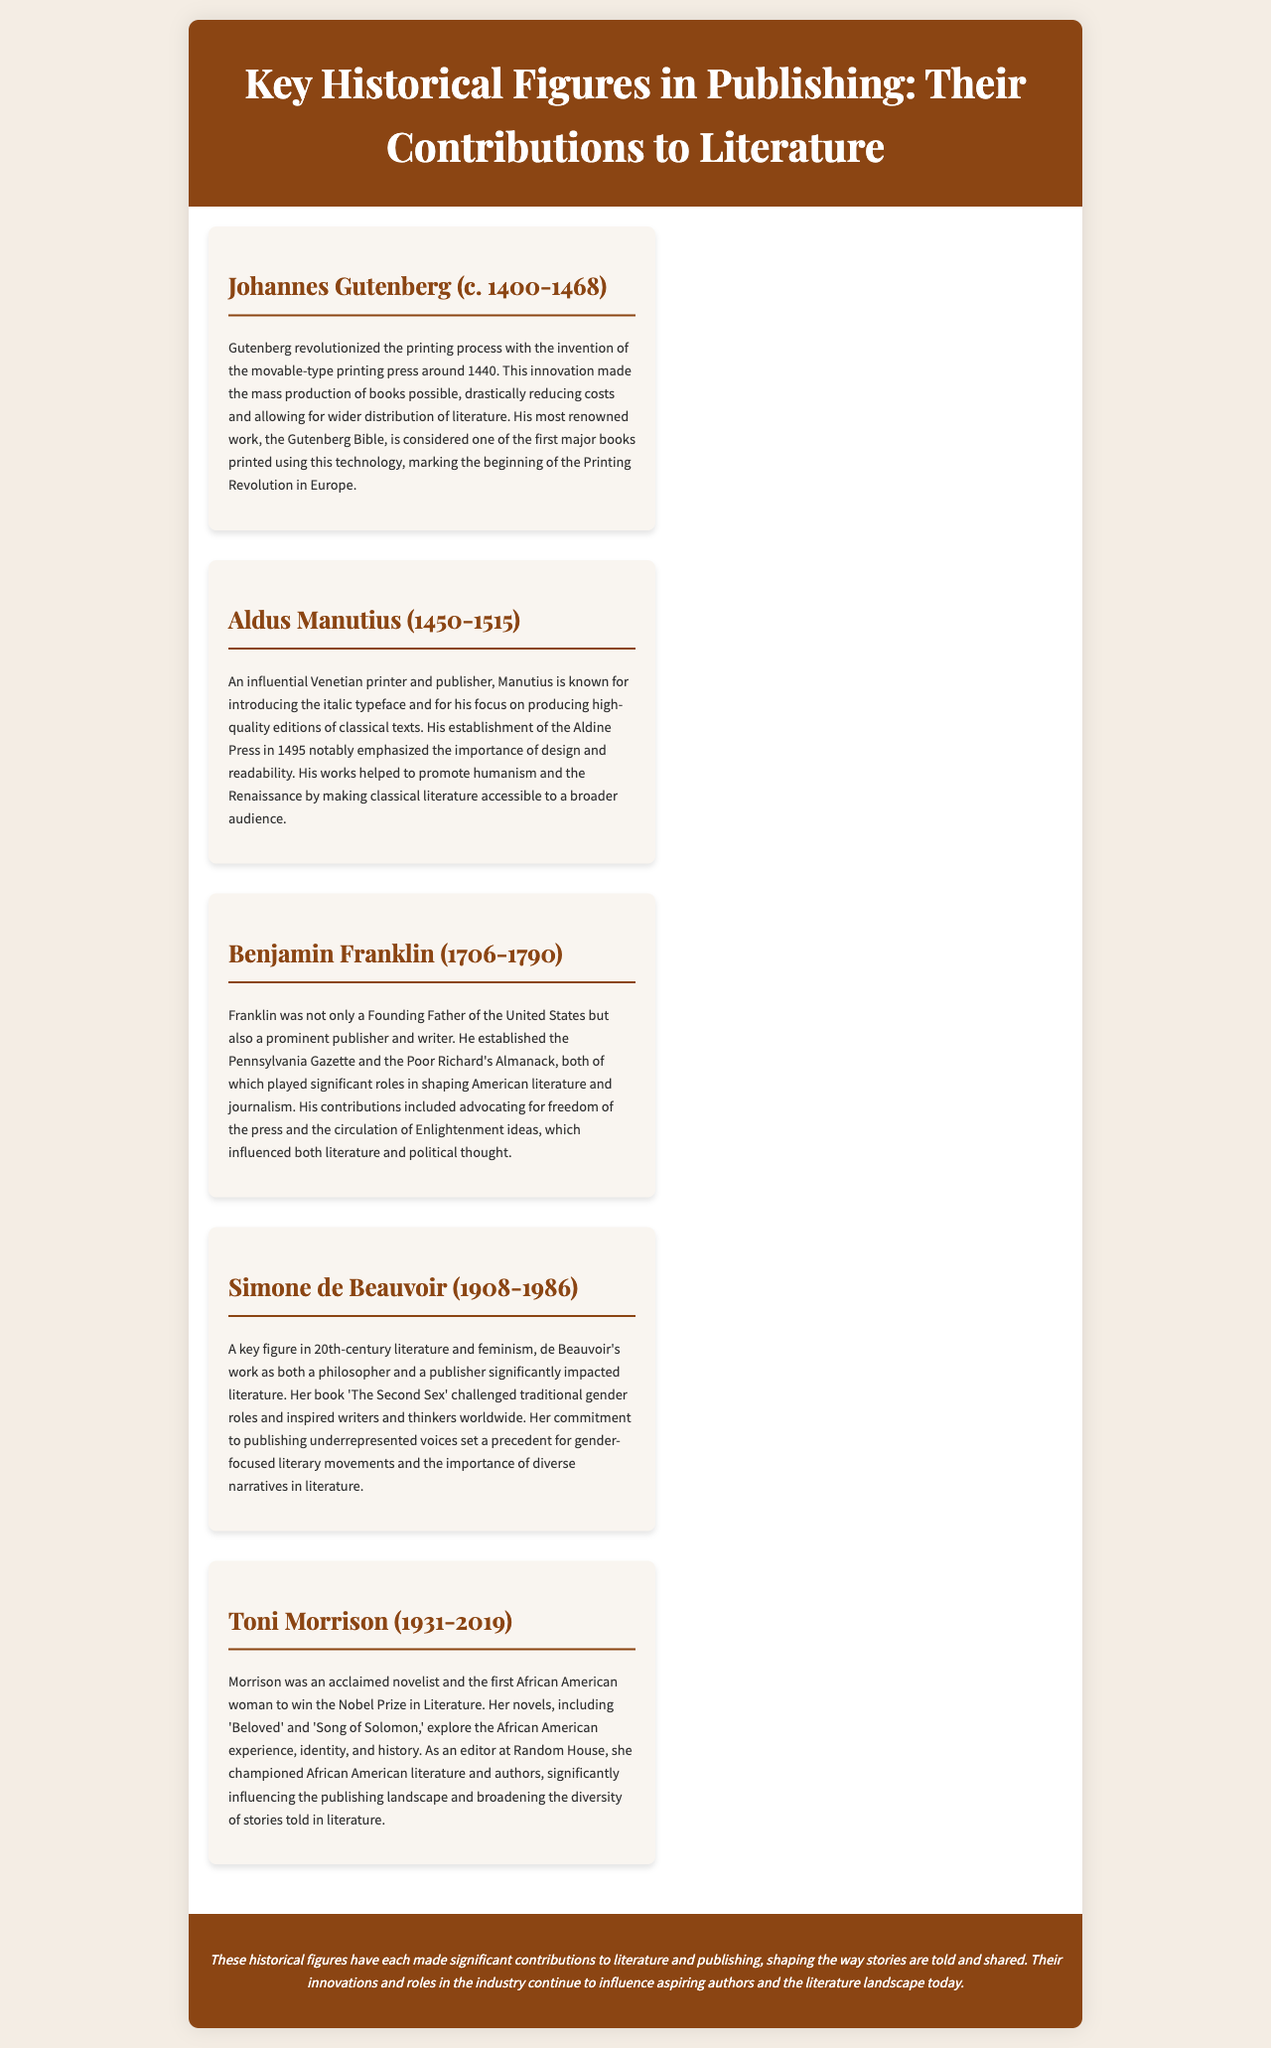What is the invention associated with Johannes Gutenberg? Gutenberg is known for the invention of the movable-type printing press, which revolutionized the printing process.
Answer: movable-type printing press What year was the Aldine Press established? Aldus Manutius established the Aldine Press in 1495, which focused on producing high-quality editions of texts.
Answer: 1495 Who wrote 'The Second Sex'? Simone de Beauvoir, a key figure in 20th-century literature, wrote 'The Second Sex,' which challenged traditional gender roles.
Answer: Simone de Beauvoir Which literary prize did Toni Morrison win? Toni Morrison was the first African American woman to win the Nobel Prize in Literature for her contributions.
Answer: Nobel Prize What role did Benjamin Franklin play in American journalism? Franklin established the Pennsylvania Gazette and the Poor Richard's Almanack, greatly impacting American literature.
Answer: publisher How did Aldus Manutius contribute to the Renaissance? Manutius emphasized the importance of design and readability, helping to promote humanism and making classical literature accessible.
Answer: design and readability Which historical figure's work set a precedent for gender-focused literary movements? Simone de Beauvoir's commitment to publishing underrepresented voices influenced gender-focused literary movements.
Answer: Simone de Beauvoir What is the main theme of Toni Morrison's novels? Morrison's novels explore the African American experience, identity, and history, broadening the diversity of stories in literature.
Answer: African American experience How did these figures influence literature? The figures made significant contributions that shaped storytelling, publication practices, and representation in literature.
Answer: significant contributions 